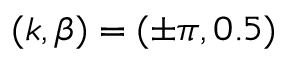<formula> <loc_0><loc_0><loc_500><loc_500>( k , \beta ) = ( \pm \pi , 0 . 5 )</formula> 